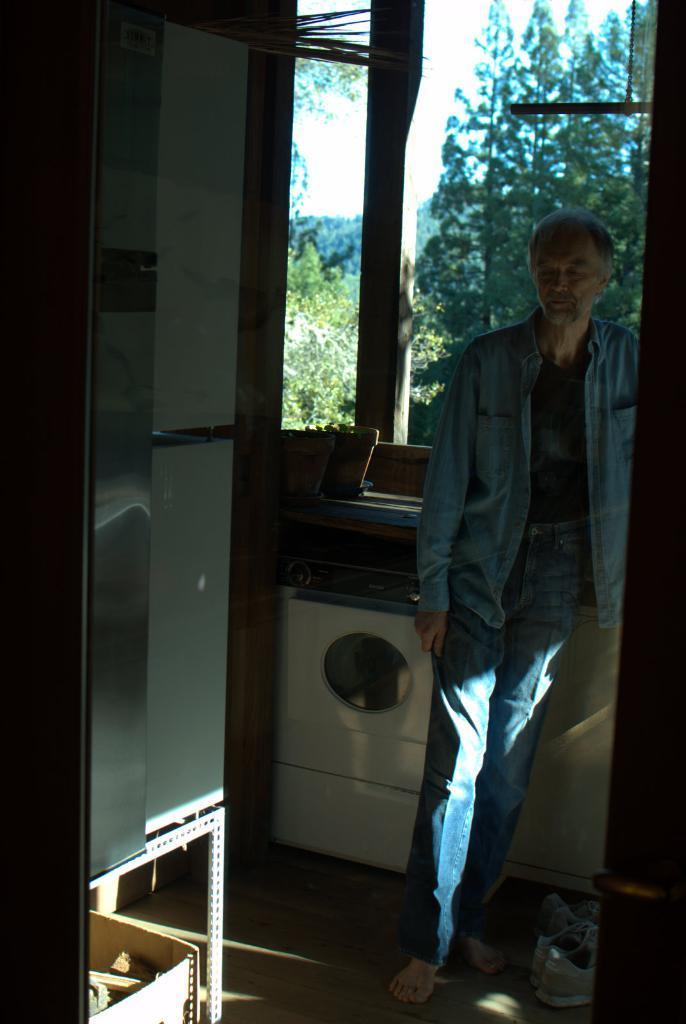Please provide a concise description of this image. In this image I can see one man is standing and I can see he is wearing blue colour of dress. On the right bottom side of this image I can see two white colour shoes and in the background I can see a washing machine, number of trees and the sky. I can also see a box on the bottom left side of the image. 